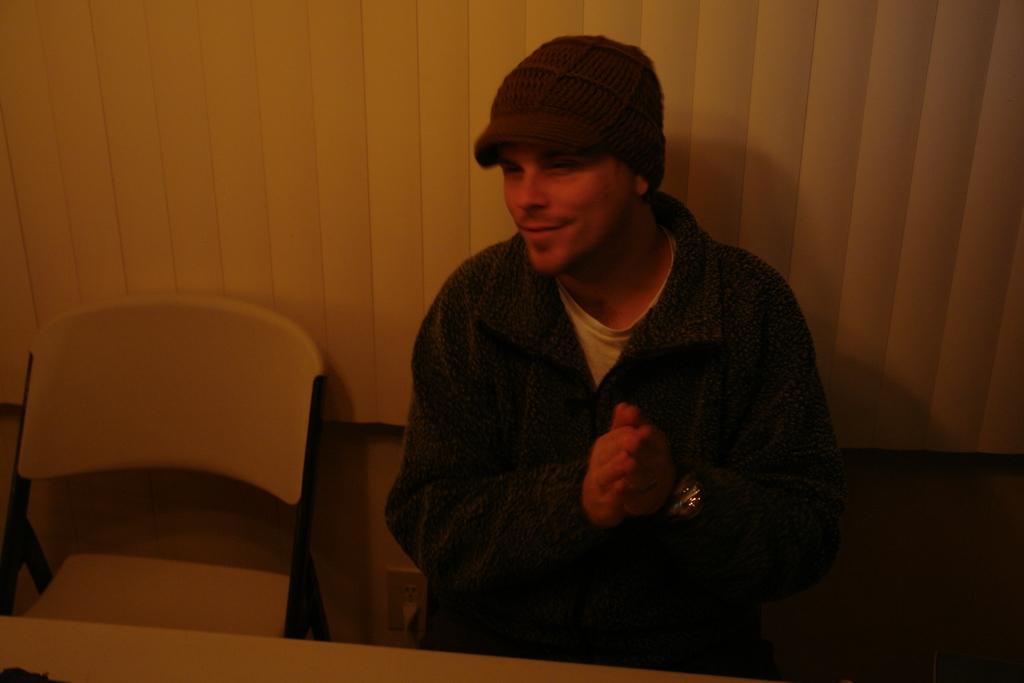How would you summarize this image in a sentence or two? In this image we can see a man is sitting. He is wearing a T-shirt, jacket and cap. Beside the man, we can see a chair. In the background, we can see a white color curtain like object. It seems like a table at the bottom of the image. 